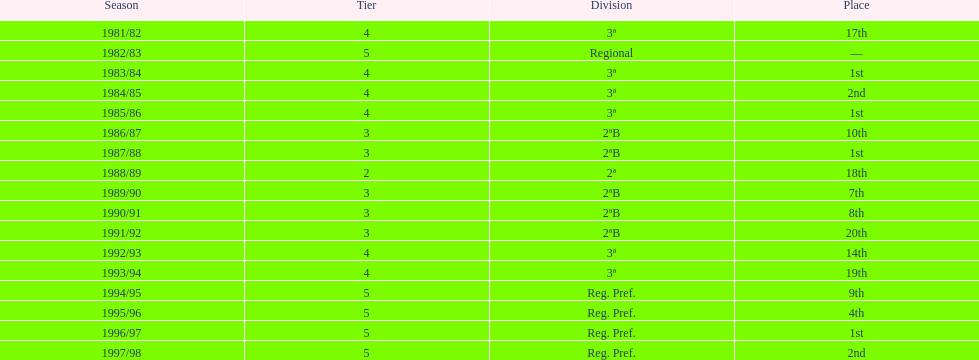Which season(s) achieved first place? 1983/84, 1985/86, 1987/88, 1996/97. 